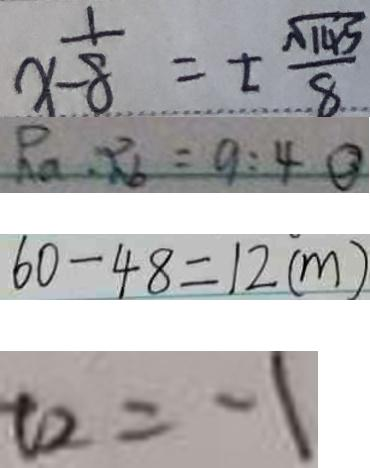Convert formula to latex. <formula><loc_0><loc_0><loc_500><loc_500>x - \frac { 1 } { 8 } = \pm \frac { \sqrt { 1 4 5 } } { 8 } 
 R _ { a } \cdot R _ { b } = 9 : 4 \textcircled { 3 } 
 6 0 - 4 8 = 1 2 ( m ) 
 t _ { 2 } = - 1</formula> 